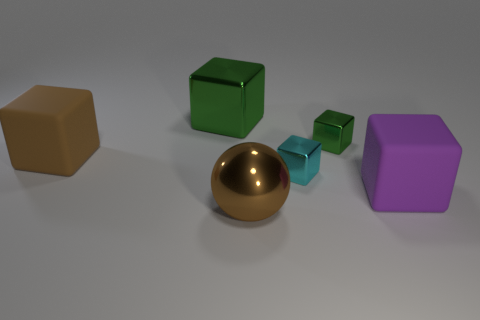Subtract all small green blocks. How many blocks are left? 4 Subtract all cyan blocks. How many blocks are left? 4 Subtract all blue blocks. Subtract all blue balls. How many blocks are left? 5 Add 3 brown metal things. How many objects exist? 9 Subtract all balls. How many objects are left? 5 Add 1 green shiny blocks. How many green shiny blocks exist? 3 Subtract 0 brown cylinders. How many objects are left? 6 Subtract all yellow metallic blocks. Subtract all large purple matte objects. How many objects are left? 5 Add 6 large purple rubber things. How many large purple rubber things are left? 7 